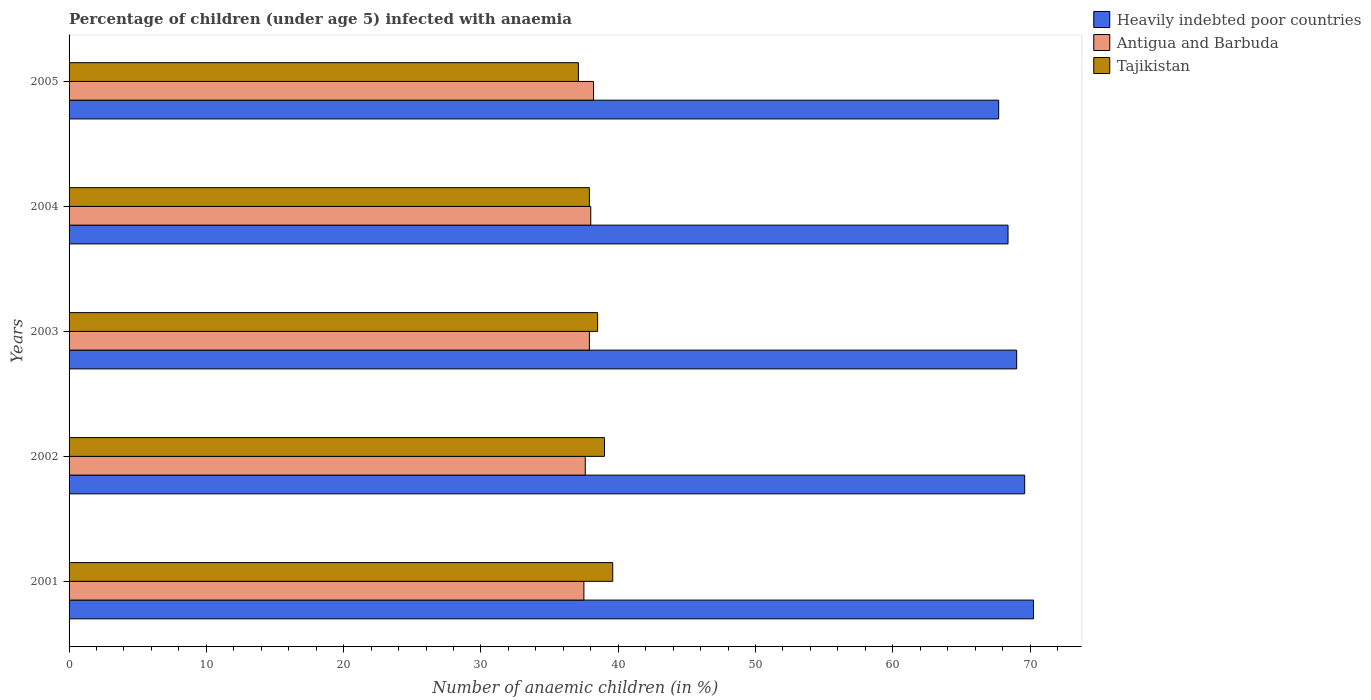How many different coloured bars are there?
Ensure brevity in your answer.  3. How many groups of bars are there?
Provide a succinct answer. 5. Are the number of bars on each tick of the Y-axis equal?
Your answer should be very brief. Yes. How many bars are there on the 1st tick from the top?
Make the answer very short. 3. How many bars are there on the 2nd tick from the bottom?
Offer a very short reply. 3. What is the label of the 3rd group of bars from the top?
Ensure brevity in your answer.  2003. What is the percentage of children infected with anaemia in in Tajikistan in 2004?
Provide a short and direct response. 37.9. Across all years, what is the maximum percentage of children infected with anaemia in in Tajikistan?
Your answer should be very brief. 39.6. Across all years, what is the minimum percentage of children infected with anaemia in in Heavily indebted poor countries?
Offer a very short reply. 67.71. What is the total percentage of children infected with anaemia in in Antigua and Barbuda in the graph?
Provide a short and direct response. 189.2. What is the difference between the percentage of children infected with anaemia in in Heavily indebted poor countries in 2001 and that in 2004?
Provide a succinct answer. 1.86. What is the difference between the percentage of children infected with anaemia in in Heavily indebted poor countries in 2004 and the percentage of children infected with anaemia in in Tajikistan in 2001?
Ensure brevity in your answer.  28.79. What is the average percentage of children infected with anaemia in in Tajikistan per year?
Your answer should be very brief. 38.42. In the year 2003, what is the difference between the percentage of children infected with anaemia in in Antigua and Barbuda and percentage of children infected with anaemia in in Heavily indebted poor countries?
Make the answer very short. -31.12. What is the ratio of the percentage of children infected with anaemia in in Antigua and Barbuda in 2001 to that in 2005?
Ensure brevity in your answer.  0.98. Is the difference between the percentage of children infected with anaemia in in Antigua and Barbuda in 2003 and 2004 greater than the difference between the percentage of children infected with anaemia in in Heavily indebted poor countries in 2003 and 2004?
Give a very brief answer. No. What is the difference between the highest and the second highest percentage of children infected with anaemia in in Tajikistan?
Give a very brief answer. 0.6. What is the difference between the highest and the lowest percentage of children infected with anaemia in in Heavily indebted poor countries?
Offer a very short reply. 2.54. Is the sum of the percentage of children infected with anaemia in in Heavily indebted poor countries in 2001 and 2002 greater than the maximum percentage of children infected with anaemia in in Tajikistan across all years?
Provide a succinct answer. Yes. What does the 2nd bar from the top in 2002 represents?
Ensure brevity in your answer.  Antigua and Barbuda. What does the 3rd bar from the bottom in 2002 represents?
Your answer should be very brief. Tajikistan. Is it the case that in every year, the sum of the percentage of children infected with anaemia in in Heavily indebted poor countries and percentage of children infected with anaemia in in Antigua and Barbuda is greater than the percentage of children infected with anaemia in in Tajikistan?
Offer a terse response. Yes. How many bars are there?
Ensure brevity in your answer.  15. Are all the bars in the graph horizontal?
Offer a very short reply. Yes. Are the values on the major ticks of X-axis written in scientific E-notation?
Make the answer very short. No. How are the legend labels stacked?
Make the answer very short. Vertical. What is the title of the graph?
Ensure brevity in your answer.  Percentage of children (under age 5) infected with anaemia. What is the label or title of the X-axis?
Provide a succinct answer. Number of anaemic children (in %). What is the Number of anaemic children (in %) of Heavily indebted poor countries in 2001?
Your answer should be very brief. 70.25. What is the Number of anaemic children (in %) in Antigua and Barbuda in 2001?
Give a very brief answer. 37.5. What is the Number of anaemic children (in %) in Tajikistan in 2001?
Your response must be concise. 39.6. What is the Number of anaemic children (in %) in Heavily indebted poor countries in 2002?
Keep it short and to the point. 69.61. What is the Number of anaemic children (in %) of Antigua and Barbuda in 2002?
Offer a very short reply. 37.6. What is the Number of anaemic children (in %) in Tajikistan in 2002?
Make the answer very short. 39. What is the Number of anaemic children (in %) of Heavily indebted poor countries in 2003?
Your answer should be very brief. 69.02. What is the Number of anaemic children (in %) in Antigua and Barbuda in 2003?
Keep it short and to the point. 37.9. What is the Number of anaemic children (in %) of Tajikistan in 2003?
Offer a very short reply. 38.5. What is the Number of anaemic children (in %) of Heavily indebted poor countries in 2004?
Keep it short and to the point. 68.39. What is the Number of anaemic children (in %) of Tajikistan in 2004?
Your response must be concise. 37.9. What is the Number of anaemic children (in %) of Heavily indebted poor countries in 2005?
Offer a very short reply. 67.71. What is the Number of anaemic children (in %) in Antigua and Barbuda in 2005?
Offer a terse response. 38.2. What is the Number of anaemic children (in %) in Tajikistan in 2005?
Your answer should be very brief. 37.1. Across all years, what is the maximum Number of anaemic children (in %) in Heavily indebted poor countries?
Your answer should be compact. 70.25. Across all years, what is the maximum Number of anaemic children (in %) in Antigua and Barbuda?
Provide a short and direct response. 38.2. Across all years, what is the maximum Number of anaemic children (in %) of Tajikistan?
Provide a short and direct response. 39.6. Across all years, what is the minimum Number of anaemic children (in %) of Heavily indebted poor countries?
Offer a terse response. 67.71. Across all years, what is the minimum Number of anaemic children (in %) of Antigua and Barbuda?
Give a very brief answer. 37.5. Across all years, what is the minimum Number of anaemic children (in %) of Tajikistan?
Your answer should be compact. 37.1. What is the total Number of anaemic children (in %) of Heavily indebted poor countries in the graph?
Your answer should be very brief. 344.99. What is the total Number of anaemic children (in %) of Antigua and Barbuda in the graph?
Your response must be concise. 189.2. What is the total Number of anaemic children (in %) of Tajikistan in the graph?
Offer a terse response. 192.1. What is the difference between the Number of anaemic children (in %) in Heavily indebted poor countries in 2001 and that in 2002?
Provide a succinct answer. 0.64. What is the difference between the Number of anaemic children (in %) of Tajikistan in 2001 and that in 2002?
Provide a short and direct response. 0.6. What is the difference between the Number of anaemic children (in %) of Heavily indebted poor countries in 2001 and that in 2003?
Provide a short and direct response. 1.23. What is the difference between the Number of anaemic children (in %) of Antigua and Barbuda in 2001 and that in 2003?
Provide a short and direct response. -0.4. What is the difference between the Number of anaemic children (in %) of Heavily indebted poor countries in 2001 and that in 2004?
Your answer should be very brief. 1.86. What is the difference between the Number of anaemic children (in %) in Tajikistan in 2001 and that in 2004?
Provide a succinct answer. 1.7. What is the difference between the Number of anaemic children (in %) in Heavily indebted poor countries in 2001 and that in 2005?
Offer a very short reply. 2.54. What is the difference between the Number of anaemic children (in %) in Antigua and Barbuda in 2001 and that in 2005?
Your answer should be compact. -0.7. What is the difference between the Number of anaemic children (in %) in Heavily indebted poor countries in 2002 and that in 2003?
Make the answer very short. 0.58. What is the difference between the Number of anaemic children (in %) in Antigua and Barbuda in 2002 and that in 2003?
Your answer should be very brief. -0.3. What is the difference between the Number of anaemic children (in %) of Tajikistan in 2002 and that in 2003?
Keep it short and to the point. 0.5. What is the difference between the Number of anaemic children (in %) of Heavily indebted poor countries in 2002 and that in 2004?
Make the answer very short. 1.21. What is the difference between the Number of anaemic children (in %) in Antigua and Barbuda in 2002 and that in 2004?
Make the answer very short. -0.4. What is the difference between the Number of anaemic children (in %) of Heavily indebted poor countries in 2002 and that in 2005?
Your answer should be compact. 1.9. What is the difference between the Number of anaemic children (in %) in Heavily indebted poor countries in 2003 and that in 2004?
Keep it short and to the point. 0.63. What is the difference between the Number of anaemic children (in %) in Antigua and Barbuda in 2003 and that in 2004?
Offer a very short reply. -0.1. What is the difference between the Number of anaemic children (in %) of Tajikistan in 2003 and that in 2004?
Give a very brief answer. 0.6. What is the difference between the Number of anaemic children (in %) of Heavily indebted poor countries in 2003 and that in 2005?
Your answer should be compact. 1.31. What is the difference between the Number of anaemic children (in %) in Heavily indebted poor countries in 2004 and that in 2005?
Keep it short and to the point. 0.68. What is the difference between the Number of anaemic children (in %) in Tajikistan in 2004 and that in 2005?
Offer a very short reply. 0.8. What is the difference between the Number of anaemic children (in %) in Heavily indebted poor countries in 2001 and the Number of anaemic children (in %) in Antigua and Barbuda in 2002?
Provide a succinct answer. 32.65. What is the difference between the Number of anaemic children (in %) of Heavily indebted poor countries in 2001 and the Number of anaemic children (in %) of Tajikistan in 2002?
Provide a succinct answer. 31.25. What is the difference between the Number of anaemic children (in %) in Antigua and Barbuda in 2001 and the Number of anaemic children (in %) in Tajikistan in 2002?
Keep it short and to the point. -1.5. What is the difference between the Number of anaemic children (in %) of Heavily indebted poor countries in 2001 and the Number of anaemic children (in %) of Antigua and Barbuda in 2003?
Your answer should be compact. 32.35. What is the difference between the Number of anaemic children (in %) of Heavily indebted poor countries in 2001 and the Number of anaemic children (in %) of Tajikistan in 2003?
Your response must be concise. 31.75. What is the difference between the Number of anaemic children (in %) in Heavily indebted poor countries in 2001 and the Number of anaemic children (in %) in Antigua and Barbuda in 2004?
Your response must be concise. 32.25. What is the difference between the Number of anaemic children (in %) in Heavily indebted poor countries in 2001 and the Number of anaemic children (in %) in Tajikistan in 2004?
Make the answer very short. 32.35. What is the difference between the Number of anaemic children (in %) of Antigua and Barbuda in 2001 and the Number of anaemic children (in %) of Tajikistan in 2004?
Your response must be concise. -0.4. What is the difference between the Number of anaemic children (in %) in Heavily indebted poor countries in 2001 and the Number of anaemic children (in %) in Antigua and Barbuda in 2005?
Your response must be concise. 32.05. What is the difference between the Number of anaemic children (in %) in Heavily indebted poor countries in 2001 and the Number of anaemic children (in %) in Tajikistan in 2005?
Ensure brevity in your answer.  33.15. What is the difference between the Number of anaemic children (in %) in Heavily indebted poor countries in 2002 and the Number of anaemic children (in %) in Antigua and Barbuda in 2003?
Your answer should be very brief. 31.71. What is the difference between the Number of anaemic children (in %) in Heavily indebted poor countries in 2002 and the Number of anaemic children (in %) in Tajikistan in 2003?
Your answer should be compact. 31.11. What is the difference between the Number of anaemic children (in %) in Heavily indebted poor countries in 2002 and the Number of anaemic children (in %) in Antigua and Barbuda in 2004?
Provide a succinct answer. 31.61. What is the difference between the Number of anaemic children (in %) in Heavily indebted poor countries in 2002 and the Number of anaemic children (in %) in Tajikistan in 2004?
Your answer should be compact. 31.71. What is the difference between the Number of anaemic children (in %) of Antigua and Barbuda in 2002 and the Number of anaemic children (in %) of Tajikistan in 2004?
Provide a succinct answer. -0.3. What is the difference between the Number of anaemic children (in %) of Heavily indebted poor countries in 2002 and the Number of anaemic children (in %) of Antigua and Barbuda in 2005?
Provide a short and direct response. 31.41. What is the difference between the Number of anaemic children (in %) of Heavily indebted poor countries in 2002 and the Number of anaemic children (in %) of Tajikistan in 2005?
Offer a terse response. 32.51. What is the difference between the Number of anaemic children (in %) in Heavily indebted poor countries in 2003 and the Number of anaemic children (in %) in Antigua and Barbuda in 2004?
Your answer should be compact. 31.02. What is the difference between the Number of anaemic children (in %) of Heavily indebted poor countries in 2003 and the Number of anaemic children (in %) of Tajikistan in 2004?
Your response must be concise. 31.12. What is the difference between the Number of anaemic children (in %) of Heavily indebted poor countries in 2003 and the Number of anaemic children (in %) of Antigua and Barbuda in 2005?
Your response must be concise. 30.82. What is the difference between the Number of anaemic children (in %) of Heavily indebted poor countries in 2003 and the Number of anaemic children (in %) of Tajikistan in 2005?
Make the answer very short. 31.92. What is the difference between the Number of anaemic children (in %) of Antigua and Barbuda in 2003 and the Number of anaemic children (in %) of Tajikistan in 2005?
Make the answer very short. 0.8. What is the difference between the Number of anaemic children (in %) in Heavily indebted poor countries in 2004 and the Number of anaemic children (in %) in Antigua and Barbuda in 2005?
Your answer should be compact. 30.19. What is the difference between the Number of anaemic children (in %) of Heavily indebted poor countries in 2004 and the Number of anaemic children (in %) of Tajikistan in 2005?
Provide a succinct answer. 31.29. What is the difference between the Number of anaemic children (in %) of Antigua and Barbuda in 2004 and the Number of anaemic children (in %) of Tajikistan in 2005?
Keep it short and to the point. 0.9. What is the average Number of anaemic children (in %) in Heavily indebted poor countries per year?
Make the answer very short. 69. What is the average Number of anaemic children (in %) of Antigua and Barbuda per year?
Keep it short and to the point. 37.84. What is the average Number of anaemic children (in %) of Tajikistan per year?
Offer a very short reply. 38.42. In the year 2001, what is the difference between the Number of anaemic children (in %) of Heavily indebted poor countries and Number of anaemic children (in %) of Antigua and Barbuda?
Provide a succinct answer. 32.75. In the year 2001, what is the difference between the Number of anaemic children (in %) in Heavily indebted poor countries and Number of anaemic children (in %) in Tajikistan?
Provide a short and direct response. 30.65. In the year 2002, what is the difference between the Number of anaemic children (in %) of Heavily indebted poor countries and Number of anaemic children (in %) of Antigua and Barbuda?
Make the answer very short. 32.01. In the year 2002, what is the difference between the Number of anaemic children (in %) of Heavily indebted poor countries and Number of anaemic children (in %) of Tajikistan?
Give a very brief answer. 30.61. In the year 2002, what is the difference between the Number of anaemic children (in %) in Antigua and Barbuda and Number of anaemic children (in %) in Tajikistan?
Keep it short and to the point. -1.4. In the year 2003, what is the difference between the Number of anaemic children (in %) of Heavily indebted poor countries and Number of anaemic children (in %) of Antigua and Barbuda?
Your answer should be very brief. 31.12. In the year 2003, what is the difference between the Number of anaemic children (in %) of Heavily indebted poor countries and Number of anaemic children (in %) of Tajikistan?
Provide a succinct answer. 30.52. In the year 2003, what is the difference between the Number of anaemic children (in %) of Antigua and Barbuda and Number of anaemic children (in %) of Tajikistan?
Your response must be concise. -0.6. In the year 2004, what is the difference between the Number of anaemic children (in %) in Heavily indebted poor countries and Number of anaemic children (in %) in Antigua and Barbuda?
Provide a succinct answer. 30.39. In the year 2004, what is the difference between the Number of anaemic children (in %) in Heavily indebted poor countries and Number of anaemic children (in %) in Tajikistan?
Offer a very short reply. 30.49. In the year 2004, what is the difference between the Number of anaemic children (in %) of Antigua and Barbuda and Number of anaemic children (in %) of Tajikistan?
Provide a succinct answer. 0.1. In the year 2005, what is the difference between the Number of anaemic children (in %) of Heavily indebted poor countries and Number of anaemic children (in %) of Antigua and Barbuda?
Keep it short and to the point. 29.51. In the year 2005, what is the difference between the Number of anaemic children (in %) in Heavily indebted poor countries and Number of anaemic children (in %) in Tajikistan?
Give a very brief answer. 30.61. What is the ratio of the Number of anaemic children (in %) of Heavily indebted poor countries in 2001 to that in 2002?
Your answer should be compact. 1.01. What is the ratio of the Number of anaemic children (in %) of Tajikistan in 2001 to that in 2002?
Make the answer very short. 1.02. What is the ratio of the Number of anaemic children (in %) in Heavily indebted poor countries in 2001 to that in 2003?
Provide a short and direct response. 1.02. What is the ratio of the Number of anaemic children (in %) in Tajikistan in 2001 to that in 2003?
Your answer should be compact. 1.03. What is the ratio of the Number of anaemic children (in %) of Heavily indebted poor countries in 2001 to that in 2004?
Give a very brief answer. 1.03. What is the ratio of the Number of anaemic children (in %) of Antigua and Barbuda in 2001 to that in 2004?
Offer a very short reply. 0.99. What is the ratio of the Number of anaemic children (in %) of Tajikistan in 2001 to that in 2004?
Provide a succinct answer. 1.04. What is the ratio of the Number of anaemic children (in %) of Heavily indebted poor countries in 2001 to that in 2005?
Make the answer very short. 1.04. What is the ratio of the Number of anaemic children (in %) of Antigua and Barbuda in 2001 to that in 2005?
Provide a succinct answer. 0.98. What is the ratio of the Number of anaemic children (in %) in Tajikistan in 2001 to that in 2005?
Keep it short and to the point. 1.07. What is the ratio of the Number of anaemic children (in %) of Heavily indebted poor countries in 2002 to that in 2003?
Ensure brevity in your answer.  1.01. What is the ratio of the Number of anaemic children (in %) of Antigua and Barbuda in 2002 to that in 2003?
Provide a short and direct response. 0.99. What is the ratio of the Number of anaemic children (in %) in Tajikistan in 2002 to that in 2003?
Keep it short and to the point. 1.01. What is the ratio of the Number of anaemic children (in %) of Heavily indebted poor countries in 2002 to that in 2004?
Ensure brevity in your answer.  1.02. What is the ratio of the Number of anaemic children (in %) in Antigua and Barbuda in 2002 to that in 2004?
Offer a very short reply. 0.99. What is the ratio of the Number of anaemic children (in %) of Tajikistan in 2002 to that in 2004?
Offer a terse response. 1.03. What is the ratio of the Number of anaemic children (in %) of Heavily indebted poor countries in 2002 to that in 2005?
Your response must be concise. 1.03. What is the ratio of the Number of anaemic children (in %) in Antigua and Barbuda in 2002 to that in 2005?
Provide a succinct answer. 0.98. What is the ratio of the Number of anaemic children (in %) of Tajikistan in 2002 to that in 2005?
Your answer should be compact. 1.05. What is the ratio of the Number of anaemic children (in %) of Heavily indebted poor countries in 2003 to that in 2004?
Offer a very short reply. 1.01. What is the ratio of the Number of anaemic children (in %) of Antigua and Barbuda in 2003 to that in 2004?
Keep it short and to the point. 1. What is the ratio of the Number of anaemic children (in %) in Tajikistan in 2003 to that in 2004?
Provide a short and direct response. 1.02. What is the ratio of the Number of anaemic children (in %) in Heavily indebted poor countries in 2003 to that in 2005?
Provide a short and direct response. 1.02. What is the ratio of the Number of anaemic children (in %) in Antigua and Barbuda in 2003 to that in 2005?
Offer a terse response. 0.99. What is the ratio of the Number of anaemic children (in %) in Tajikistan in 2003 to that in 2005?
Provide a succinct answer. 1.04. What is the ratio of the Number of anaemic children (in %) of Tajikistan in 2004 to that in 2005?
Offer a terse response. 1.02. What is the difference between the highest and the second highest Number of anaemic children (in %) of Heavily indebted poor countries?
Your answer should be compact. 0.64. What is the difference between the highest and the lowest Number of anaemic children (in %) in Heavily indebted poor countries?
Your answer should be very brief. 2.54. What is the difference between the highest and the lowest Number of anaemic children (in %) in Antigua and Barbuda?
Provide a succinct answer. 0.7. 